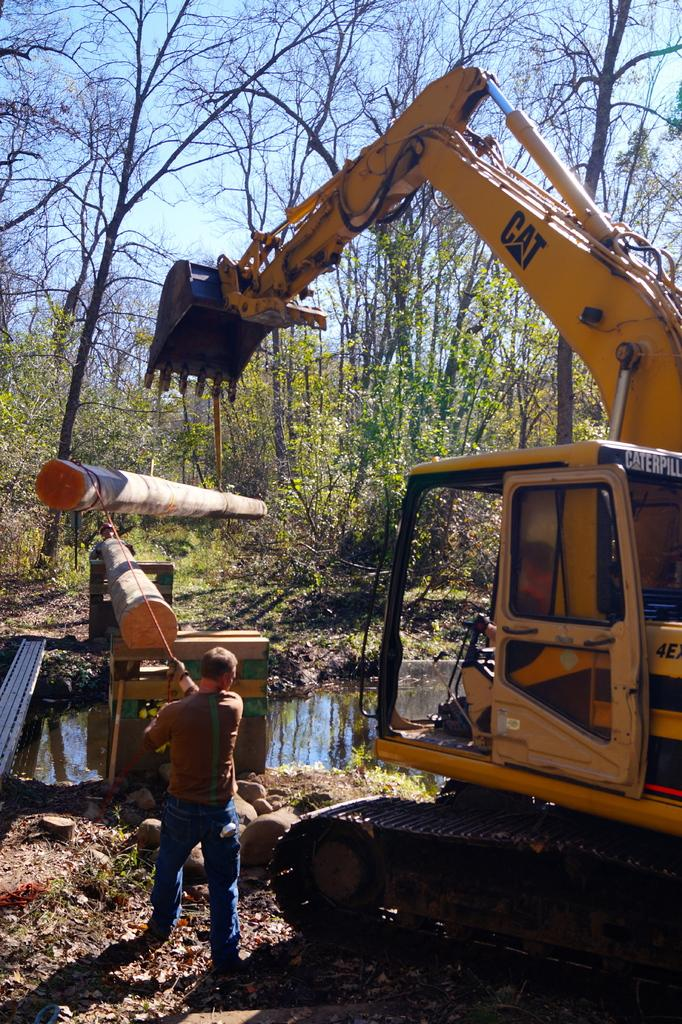What type of machinery is present in the image? There is a poclain in the image. What is the person in the image doing? The person is standing back and holding a rope. What can be seen in the water in the image? There is no specific detail about the water in the image. What type of objects are made of wood in the image? There are wooden objects in the image, but their specific nature is not mentioned. What type of vegetation is visible in the image? There are trees in the image. What is visible in the background of the image? The sky is visible in the background of the image. What type of brass ornament is hanging from the poclain in the image? There is no brass ornament hanging from the poclain in the image. How many trains can be seen in the image? There are no trains present in the image. 